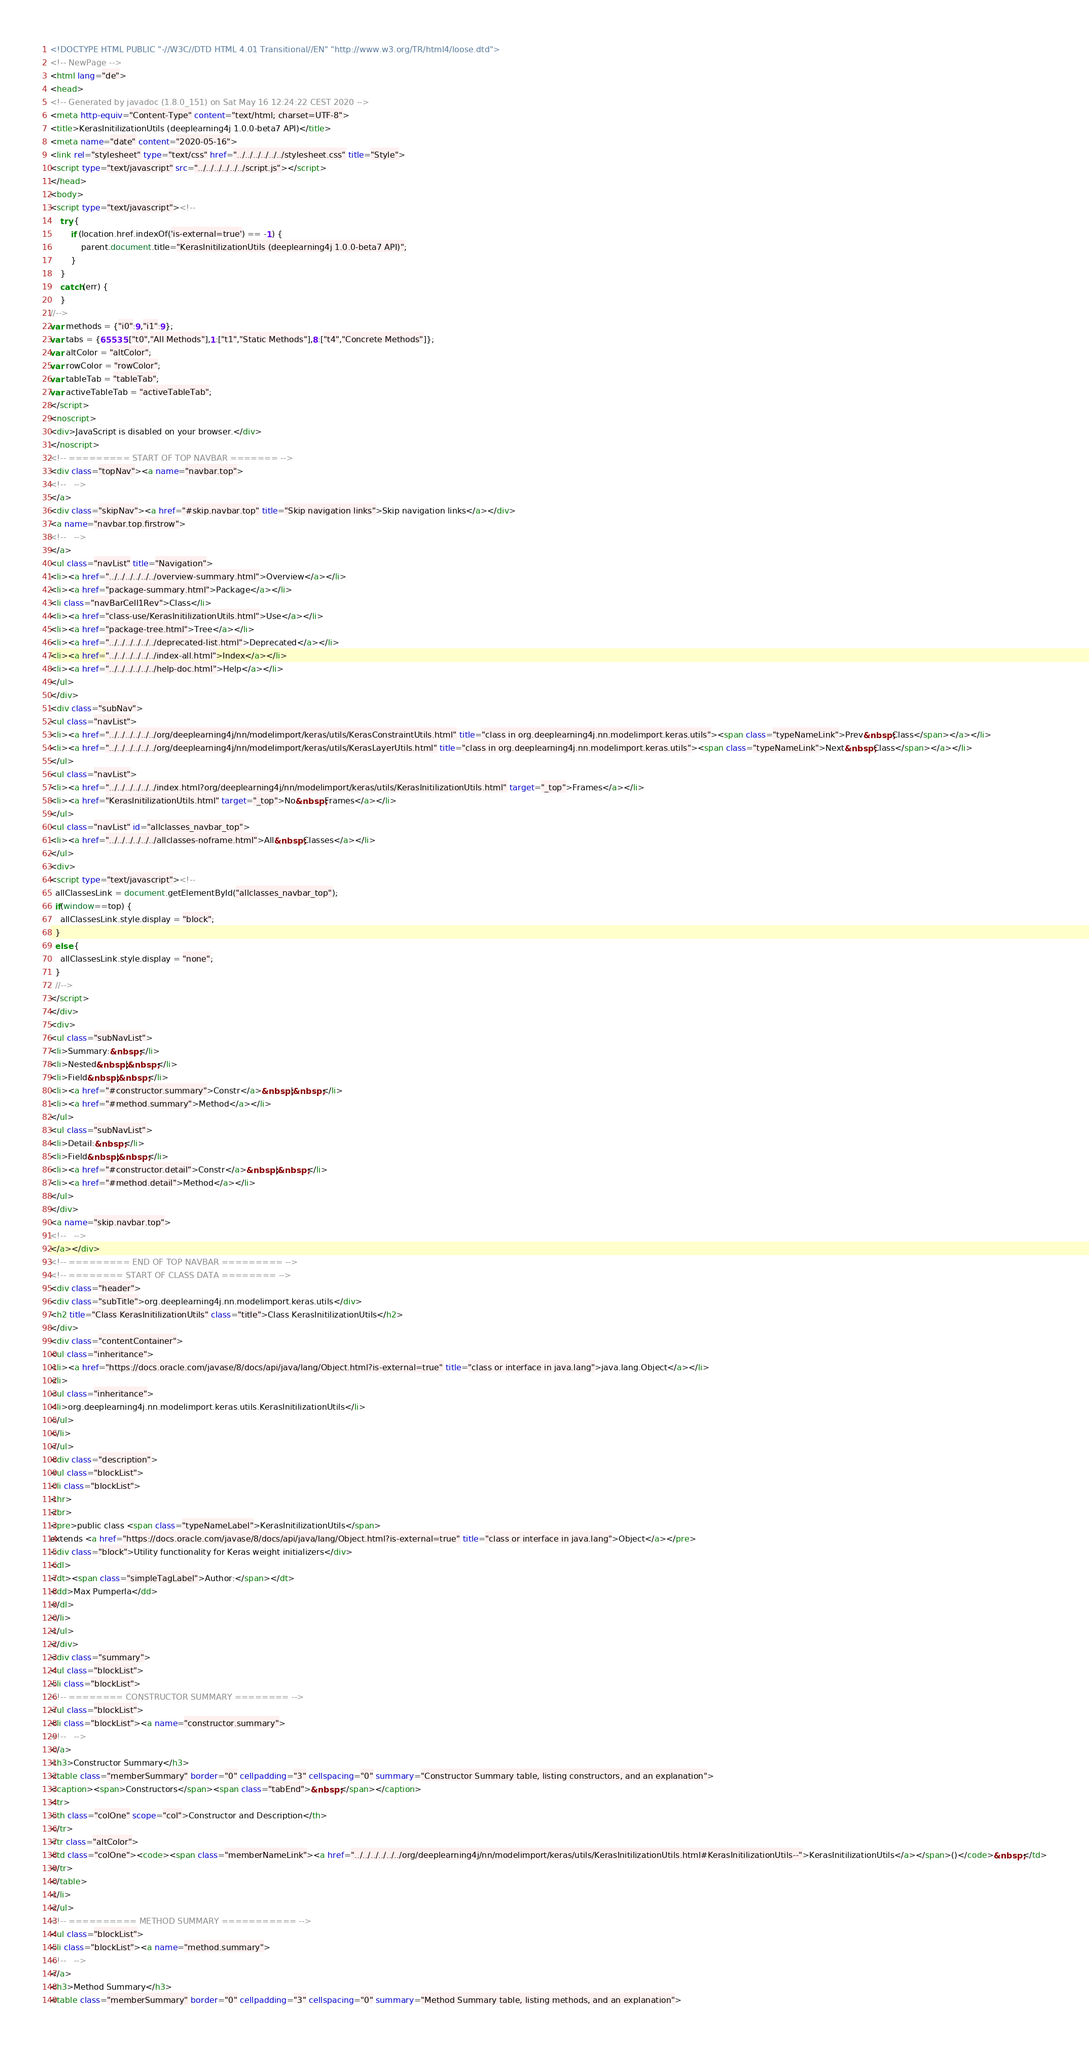<code> <loc_0><loc_0><loc_500><loc_500><_HTML_><!DOCTYPE HTML PUBLIC "-//W3C//DTD HTML 4.01 Transitional//EN" "http://www.w3.org/TR/html4/loose.dtd">
<!-- NewPage -->
<html lang="de">
<head>
<!-- Generated by javadoc (1.8.0_151) on Sat May 16 12:24:22 CEST 2020 -->
<meta http-equiv="Content-Type" content="text/html; charset=UTF-8">
<title>KerasInitilizationUtils (deeplearning4j 1.0.0-beta7 API)</title>
<meta name="date" content="2020-05-16">
<link rel="stylesheet" type="text/css" href="../../../../../../stylesheet.css" title="Style">
<script type="text/javascript" src="../../../../../../script.js"></script>
</head>
<body>
<script type="text/javascript"><!--
    try {
        if (location.href.indexOf('is-external=true') == -1) {
            parent.document.title="KerasInitilizationUtils (deeplearning4j 1.0.0-beta7 API)";
        }
    }
    catch(err) {
    }
//-->
var methods = {"i0":9,"i1":9};
var tabs = {65535:["t0","All Methods"],1:["t1","Static Methods"],8:["t4","Concrete Methods"]};
var altColor = "altColor";
var rowColor = "rowColor";
var tableTab = "tableTab";
var activeTableTab = "activeTableTab";
</script>
<noscript>
<div>JavaScript is disabled on your browser.</div>
</noscript>
<!-- ========= START OF TOP NAVBAR ======= -->
<div class="topNav"><a name="navbar.top">
<!--   -->
</a>
<div class="skipNav"><a href="#skip.navbar.top" title="Skip navigation links">Skip navigation links</a></div>
<a name="navbar.top.firstrow">
<!--   -->
</a>
<ul class="navList" title="Navigation">
<li><a href="../../../../../../overview-summary.html">Overview</a></li>
<li><a href="package-summary.html">Package</a></li>
<li class="navBarCell1Rev">Class</li>
<li><a href="class-use/KerasInitilizationUtils.html">Use</a></li>
<li><a href="package-tree.html">Tree</a></li>
<li><a href="../../../../../../deprecated-list.html">Deprecated</a></li>
<li><a href="../../../../../../index-all.html">Index</a></li>
<li><a href="../../../../../../help-doc.html">Help</a></li>
</ul>
</div>
<div class="subNav">
<ul class="navList">
<li><a href="../../../../../../org/deeplearning4j/nn/modelimport/keras/utils/KerasConstraintUtils.html" title="class in org.deeplearning4j.nn.modelimport.keras.utils"><span class="typeNameLink">Prev&nbsp;Class</span></a></li>
<li><a href="../../../../../../org/deeplearning4j/nn/modelimport/keras/utils/KerasLayerUtils.html" title="class in org.deeplearning4j.nn.modelimport.keras.utils"><span class="typeNameLink">Next&nbsp;Class</span></a></li>
</ul>
<ul class="navList">
<li><a href="../../../../../../index.html?org/deeplearning4j/nn/modelimport/keras/utils/KerasInitilizationUtils.html" target="_top">Frames</a></li>
<li><a href="KerasInitilizationUtils.html" target="_top">No&nbsp;Frames</a></li>
</ul>
<ul class="navList" id="allclasses_navbar_top">
<li><a href="../../../../../../allclasses-noframe.html">All&nbsp;Classes</a></li>
</ul>
<div>
<script type="text/javascript"><!--
  allClassesLink = document.getElementById("allclasses_navbar_top");
  if(window==top) {
    allClassesLink.style.display = "block";
  }
  else {
    allClassesLink.style.display = "none";
  }
  //-->
</script>
</div>
<div>
<ul class="subNavList">
<li>Summary:&nbsp;</li>
<li>Nested&nbsp;|&nbsp;</li>
<li>Field&nbsp;|&nbsp;</li>
<li><a href="#constructor.summary">Constr</a>&nbsp;|&nbsp;</li>
<li><a href="#method.summary">Method</a></li>
</ul>
<ul class="subNavList">
<li>Detail:&nbsp;</li>
<li>Field&nbsp;|&nbsp;</li>
<li><a href="#constructor.detail">Constr</a>&nbsp;|&nbsp;</li>
<li><a href="#method.detail">Method</a></li>
</ul>
</div>
<a name="skip.navbar.top">
<!--   -->
</a></div>
<!-- ========= END OF TOP NAVBAR ========= -->
<!-- ======== START OF CLASS DATA ======== -->
<div class="header">
<div class="subTitle">org.deeplearning4j.nn.modelimport.keras.utils</div>
<h2 title="Class KerasInitilizationUtils" class="title">Class KerasInitilizationUtils</h2>
</div>
<div class="contentContainer">
<ul class="inheritance">
<li><a href="https://docs.oracle.com/javase/8/docs/api/java/lang/Object.html?is-external=true" title="class or interface in java.lang">java.lang.Object</a></li>
<li>
<ul class="inheritance">
<li>org.deeplearning4j.nn.modelimport.keras.utils.KerasInitilizationUtils</li>
</ul>
</li>
</ul>
<div class="description">
<ul class="blockList">
<li class="blockList">
<hr>
<br>
<pre>public class <span class="typeNameLabel">KerasInitilizationUtils</span>
extends <a href="https://docs.oracle.com/javase/8/docs/api/java/lang/Object.html?is-external=true" title="class or interface in java.lang">Object</a></pre>
<div class="block">Utility functionality for Keras weight initializers</div>
<dl>
<dt><span class="simpleTagLabel">Author:</span></dt>
<dd>Max Pumperla</dd>
</dl>
</li>
</ul>
</div>
<div class="summary">
<ul class="blockList">
<li class="blockList">
<!-- ======== CONSTRUCTOR SUMMARY ======== -->
<ul class="blockList">
<li class="blockList"><a name="constructor.summary">
<!--   -->
</a>
<h3>Constructor Summary</h3>
<table class="memberSummary" border="0" cellpadding="3" cellspacing="0" summary="Constructor Summary table, listing constructors, and an explanation">
<caption><span>Constructors</span><span class="tabEnd">&nbsp;</span></caption>
<tr>
<th class="colOne" scope="col">Constructor and Description</th>
</tr>
<tr class="altColor">
<td class="colOne"><code><span class="memberNameLink"><a href="../../../../../../org/deeplearning4j/nn/modelimport/keras/utils/KerasInitilizationUtils.html#KerasInitilizationUtils--">KerasInitilizationUtils</a></span>()</code>&nbsp;</td>
</tr>
</table>
</li>
</ul>
<!-- ========== METHOD SUMMARY =========== -->
<ul class="blockList">
<li class="blockList"><a name="method.summary">
<!--   -->
</a>
<h3>Method Summary</h3>
<table class="memberSummary" border="0" cellpadding="3" cellspacing="0" summary="Method Summary table, listing methods, and an explanation"></code> 